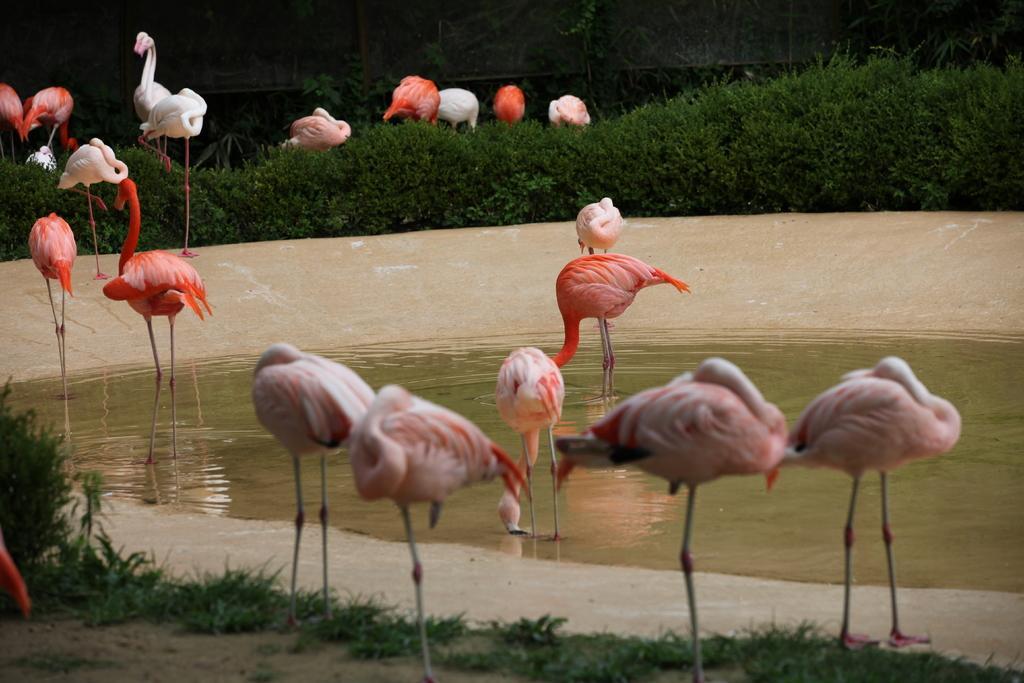Describe this image in one or two sentences. As we can see in the image there is water, cranes, grass and plants. 